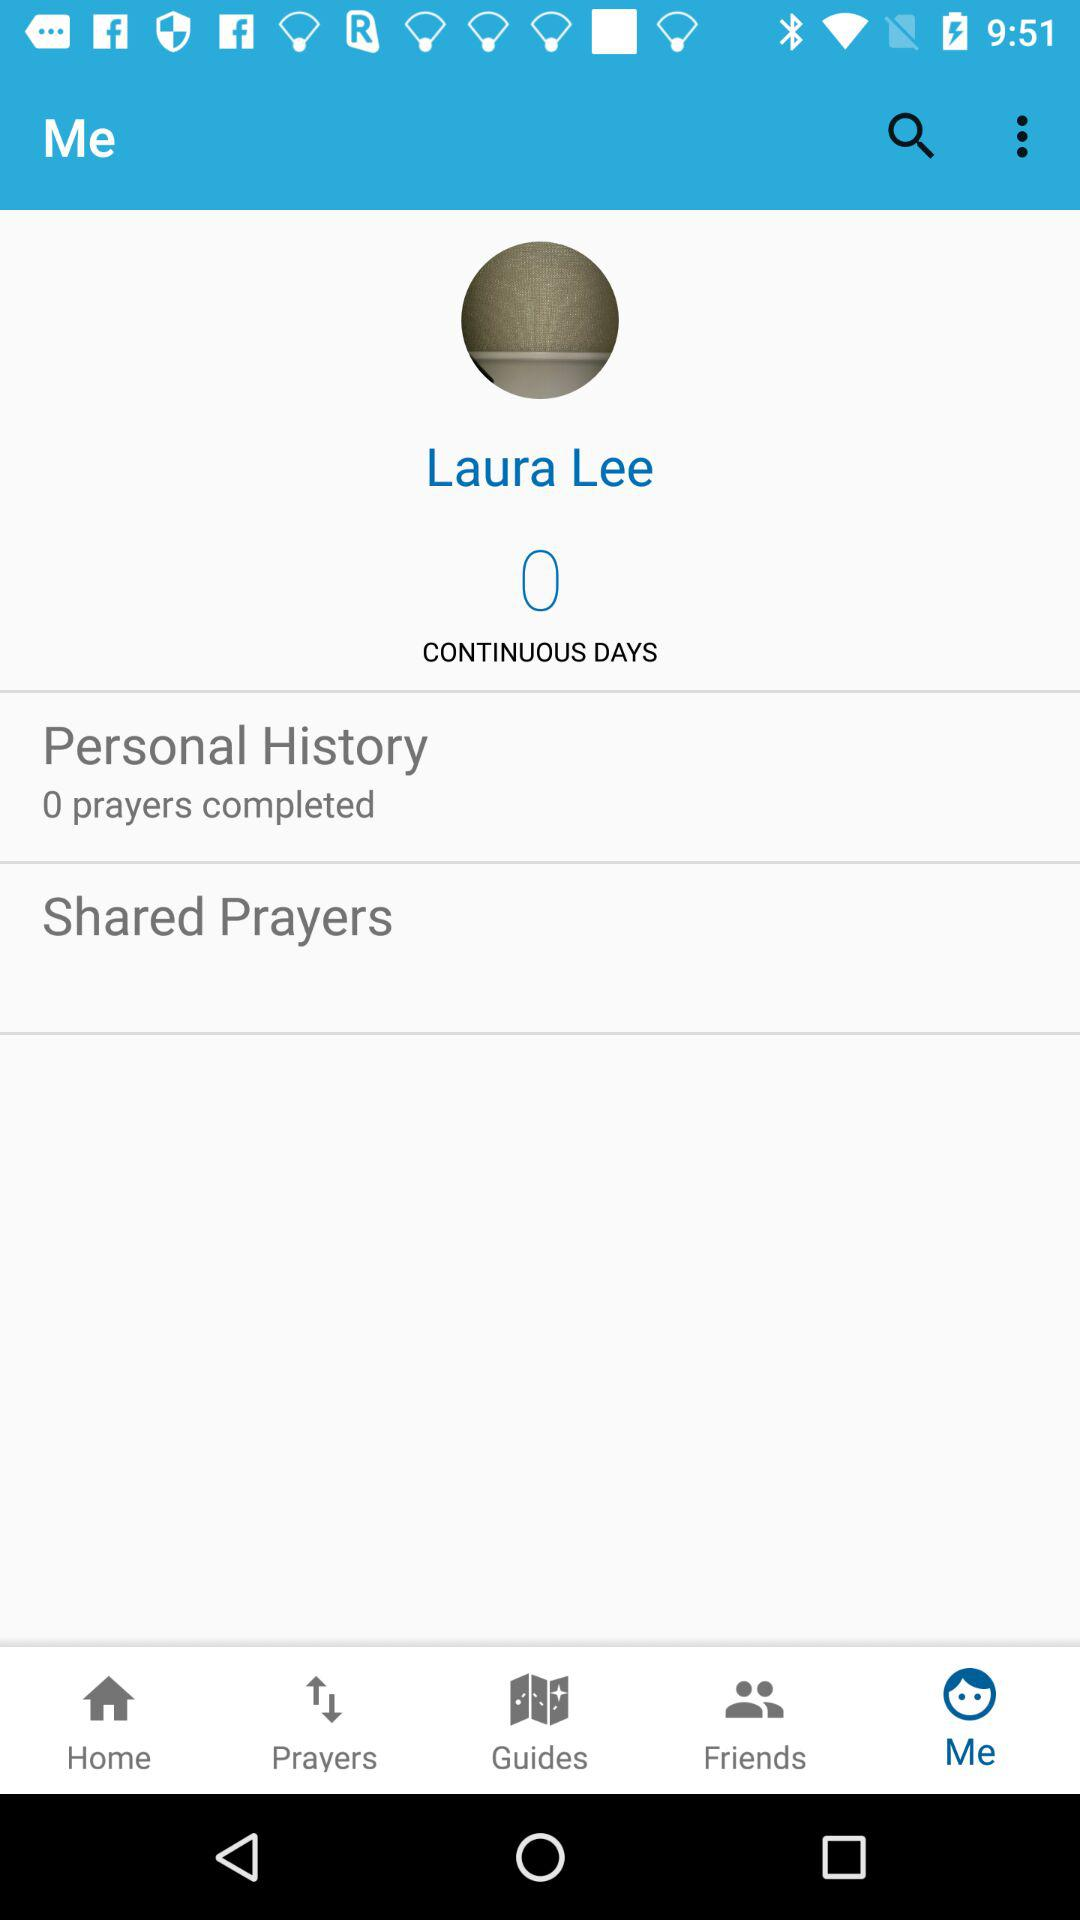How many continuous days are there? There are 0 continuous days. 